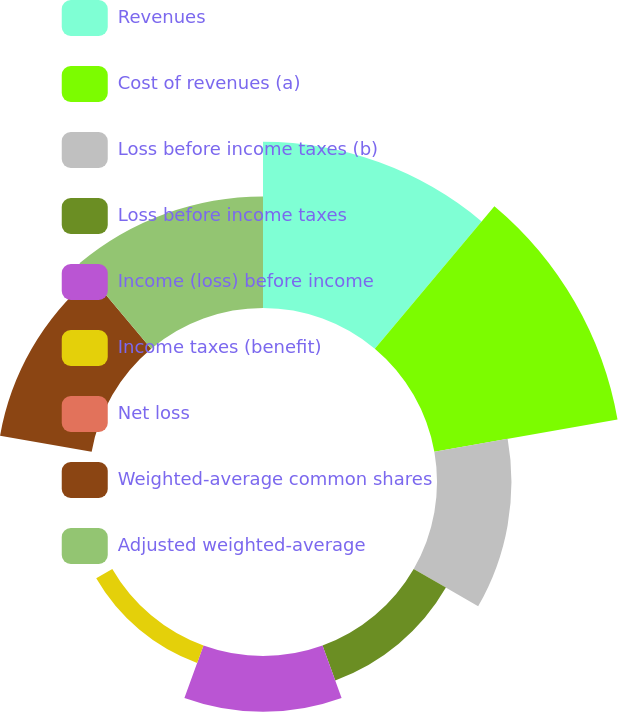Convert chart. <chart><loc_0><loc_0><loc_500><loc_500><pie_chart><fcel>Revenues<fcel>Cost of revenues (a)<fcel>Loss before income taxes (b)<fcel>Loss before income taxes<fcel>Income (loss) before income<fcel>Income taxes (benefit)<fcel>Net loss<fcel>Weighted-average common shares<fcel>Adjusted weighted-average<nl><fcel>22.37%<fcel>25.04%<fcel>10.02%<fcel>5.01%<fcel>7.51%<fcel>2.5%<fcel>0.0%<fcel>12.52%<fcel>15.02%<nl></chart> 